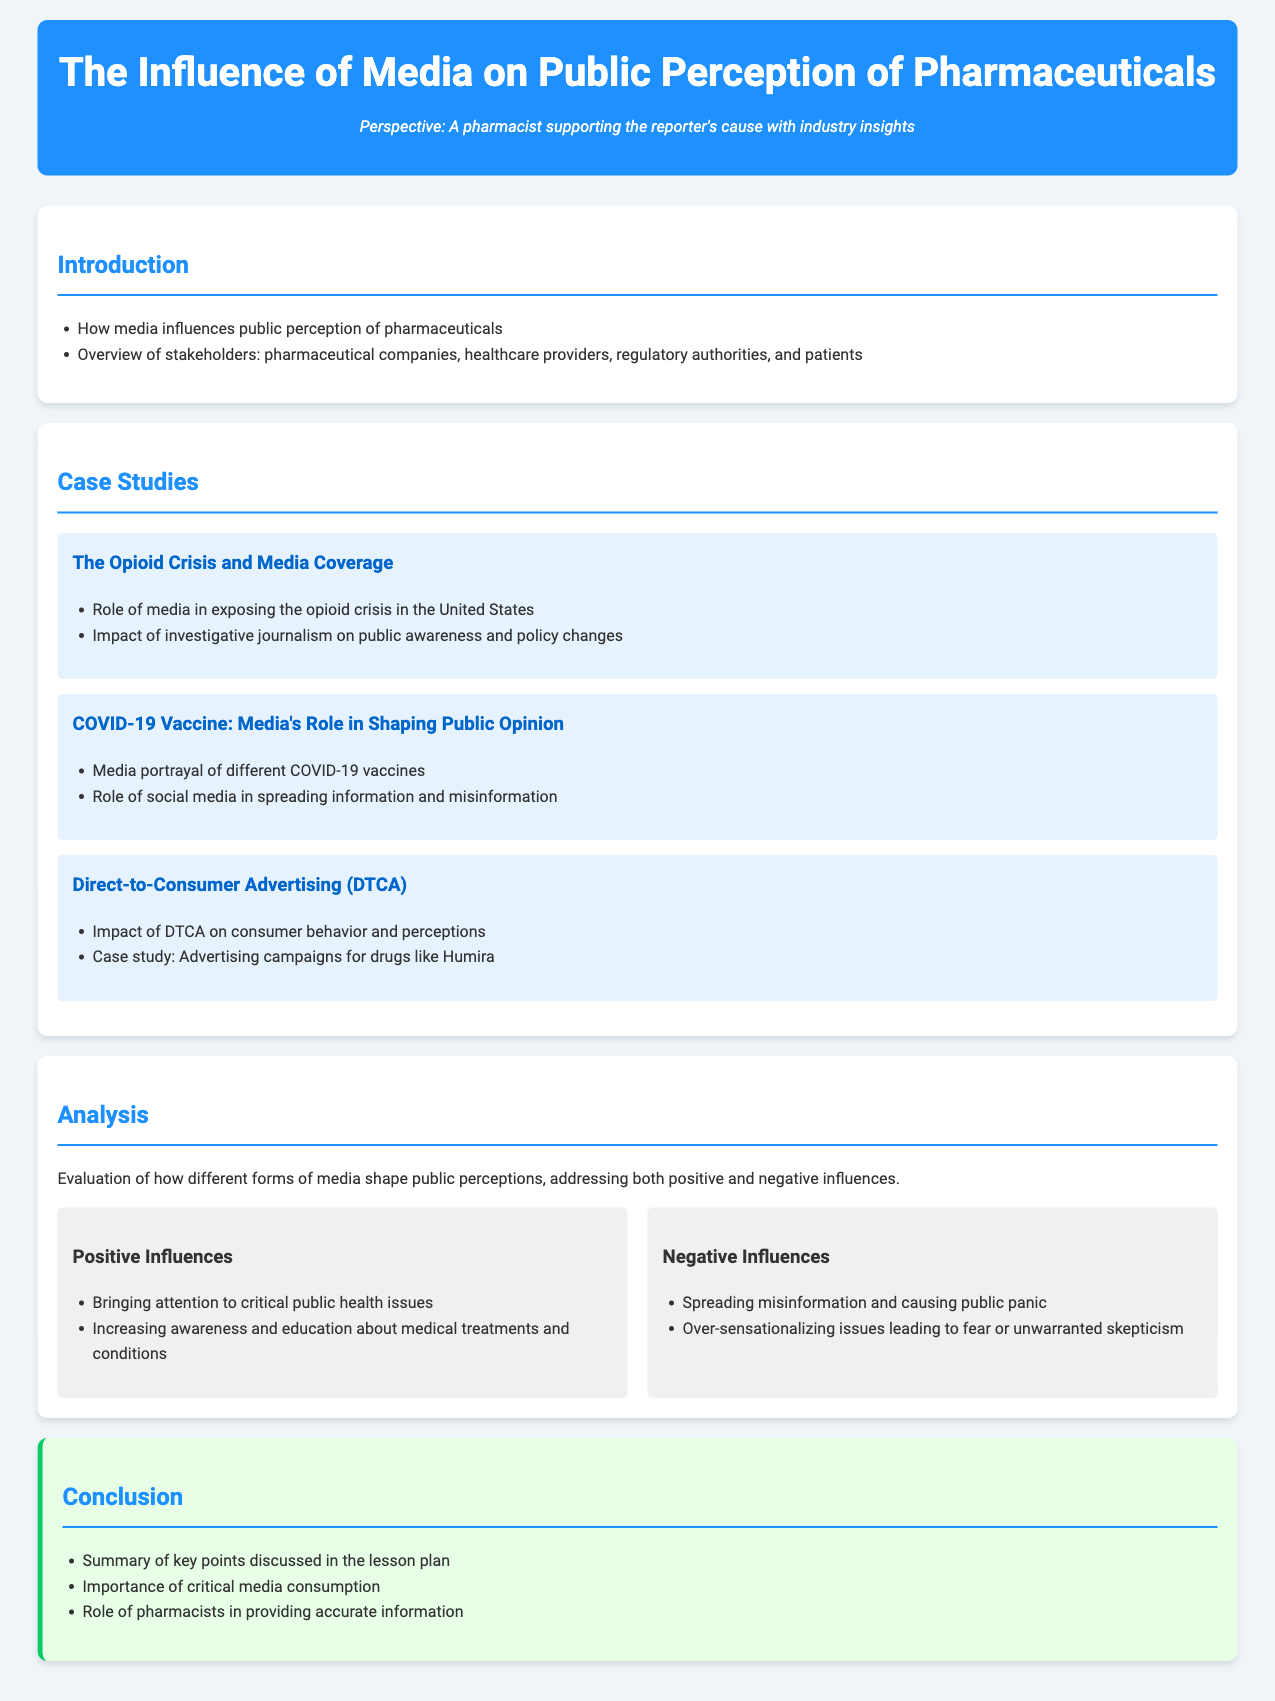What is the title of the lesson plan? The title of the lesson plan is stated in the header section of the document.
Answer: The Influence of Media on Public Perception of Pharmaceuticals What are the two major case studies discussed? The two major case studies are listed in the section titled "Case Studies."
Answer: The Opioid Crisis and COVID-19 Vaccine What is one positive influence of media on public perception? This information is provided in the "Positive Influences" analysis column in the document.
Answer: Bringing attention to critical public health issues What is one negative influence of media on public perception? This information is found in the "Negative Influences" analysis column of the document.
Answer: Spreading misinformation and causing public panic Who plays a role in critical media consumption according to the conclusion? This is mentioned in the conclusion section, indicating the involvement of certain stakeholders.
Answer: Pharmacists 